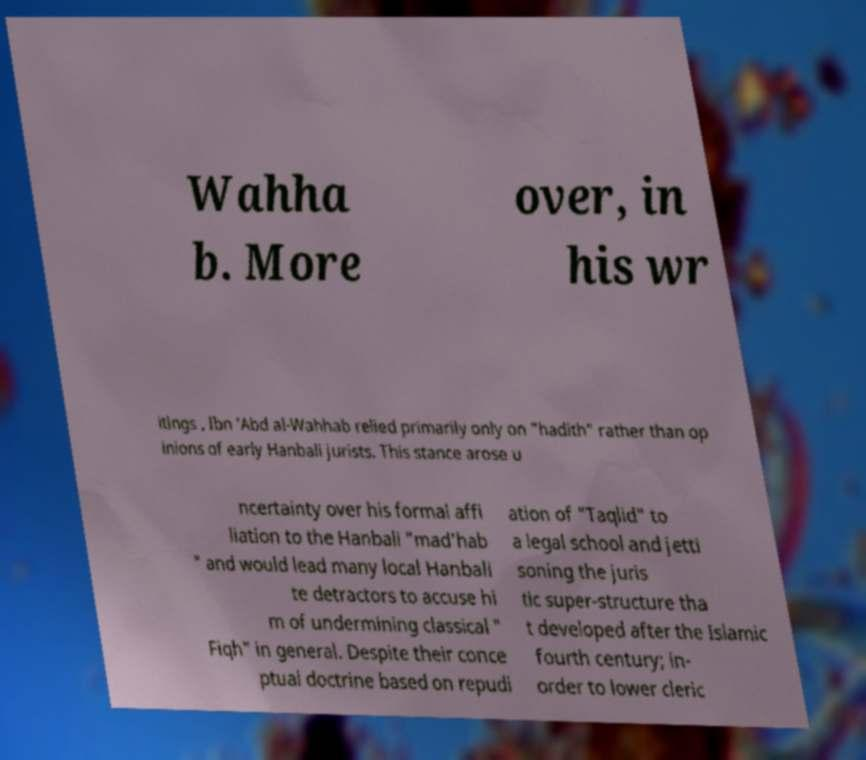Can you read and provide the text displayed in the image?This photo seems to have some interesting text. Can you extract and type it out for me? Wahha b. More over, in his wr itings , Ibn 'Abd al-Wahhab relied primarily only on "hadith" rather than op inions of early Hanbali jurists. This stance arose u ncertainty over his formal affi liation to the Hanbali "mad'hab " and would lead many local Hanbali te detractors to accuse hi m of undermining classical " Fiqh" in general. Despite their conce ptual doctrine based on repudi ation of "Taqlid" to a legal school and jetti soning the juris tic super-structure tha t developed after the Islamic fourth century; in- order to lower cleric 